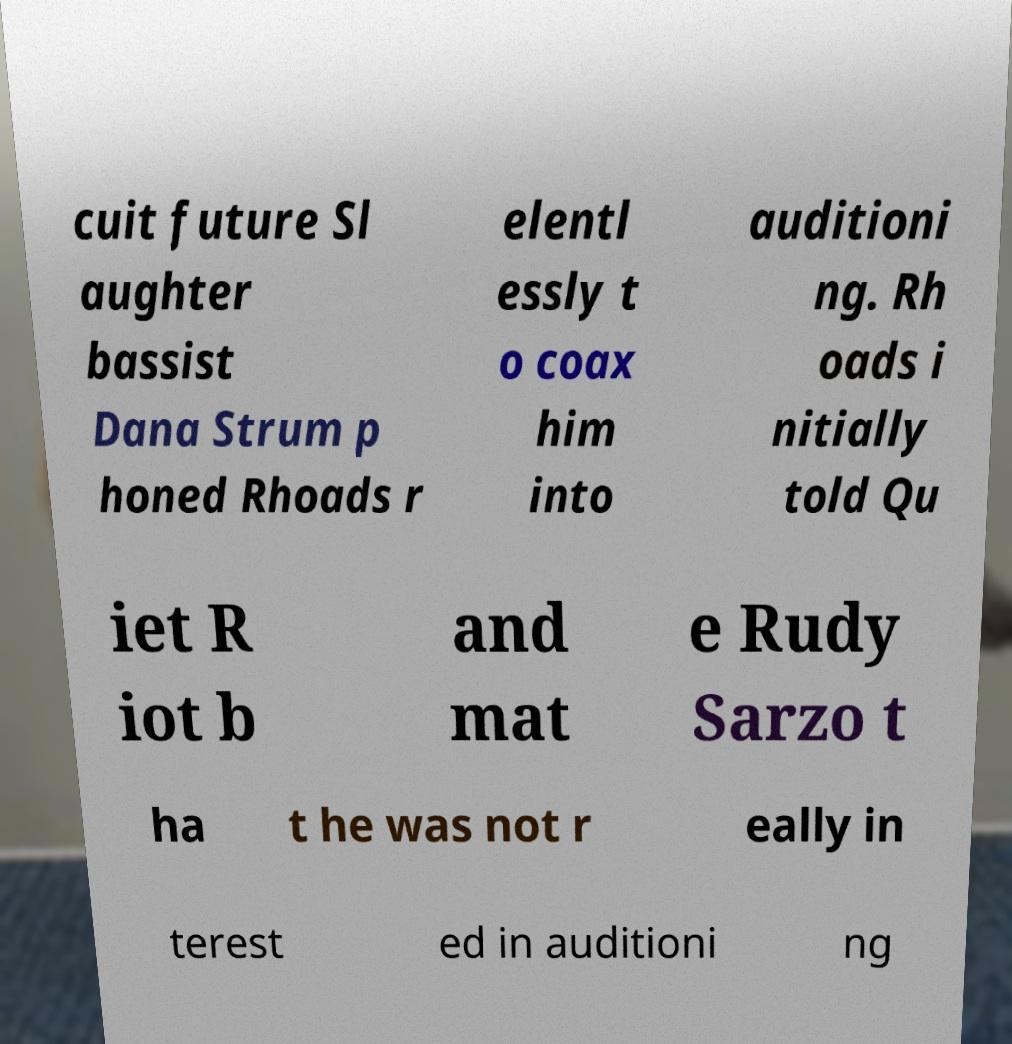Could you assist in decoding the text presented in this image and type it out clearly? cuit future Sl aughter bassist Dana Strum p honed Rhoads r elentl essly t o coax him into auditioni ng. Rh oads i nitially told Qu iet R iot b and mat e Rudy Sarzo t ha t he was not r eally in terest ed in auditioni ng 